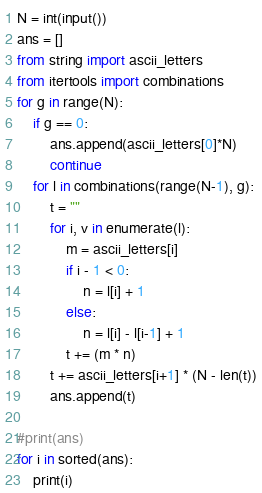Convert code to text. <code><loc_0><loc_0><loc_500><loc_500><_Python_>N = int(input())
ans = []
from string import ascii_letters
from itertools import combinations
for g in range(N):
    if g == 0:
        ans.append(ascii_letters[0]*N)
        continue
    for l in combinations(range(N-1), g):
        t = ""
        for i, v in enumerate(l):
            m = ascii_letters[i]
            if i - 1 < 0:
                n = l[i] + 1
            else:
                n = l[i] - l[i-1] + 1
            t += (m * n)
        t += ascii_letters[i+1] * (N - len(t))
        ans.append(t)

#print(ans)
for i in sorted(ans):
    print(i)
</code> 